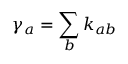<formula> <loc_0><loc_0><loc_500><loc_500>\gamma _ { a } = \sum _ { b } k _ { a b }</formula> 